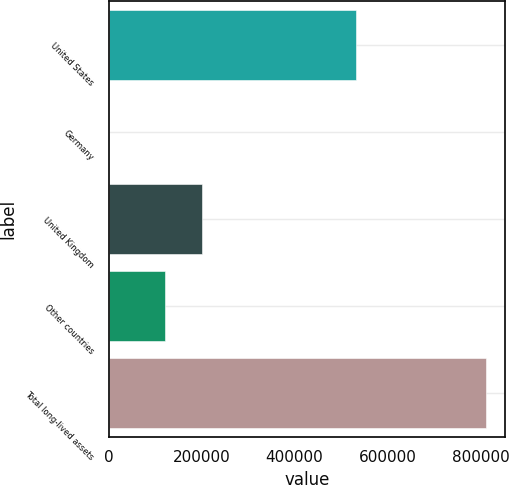<chart> <loc_0><loc_0><loc_500><loc_500><bar_chart><fcel>United States<fcel>Germany<fcel>United Kingdom<fcel>Other countries<fcel>Total long-lived assets<nl><fcel>531425<fcel>19<fcel>201599<fcel>120443<fcel>811576<nl></chart> 